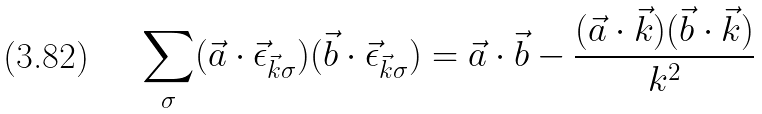Convert formula to latex. <formula><loc_0><loc_0><loc_500><loc_500>\sum _ { \sigma } ( \vec { a } \cdot \vec { \epsilon } _ { \vec { k } \sigma } ) ( \vec { b } \cdot \vec { \epsilon } _ { \vec { k } \sigma } ) = \vec { a } \cdot \vec { b } - \frac { ( \vec { a } \cdot \vec { k } ) ( \vec { b } \cdot \vec { k } ) } { k ^ { 2 } }</formula> 